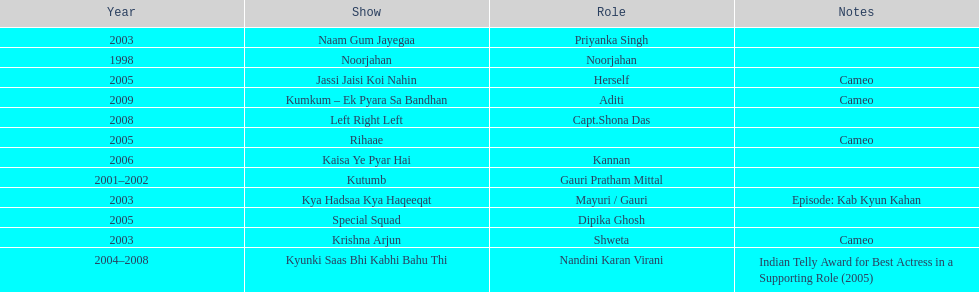How many shows were there in 2005? 3. 